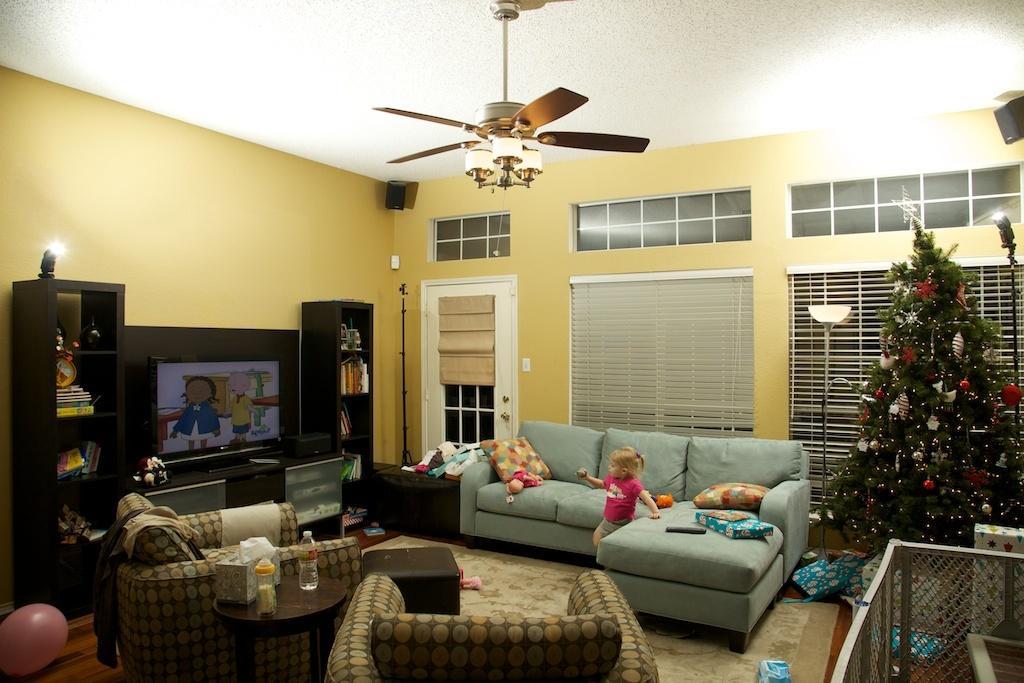Please provide a concise description of this image. In this picture we can see chairs, bottles, stool, tissue paper, box, television, toys, books in racks, sofa with pillows, box, toys, remote on it, Christmas tree with decorative items on it, lamp, fan and some objects and a girl standing on the floor and in the background we can see windows with curtains, walls, speakers. 